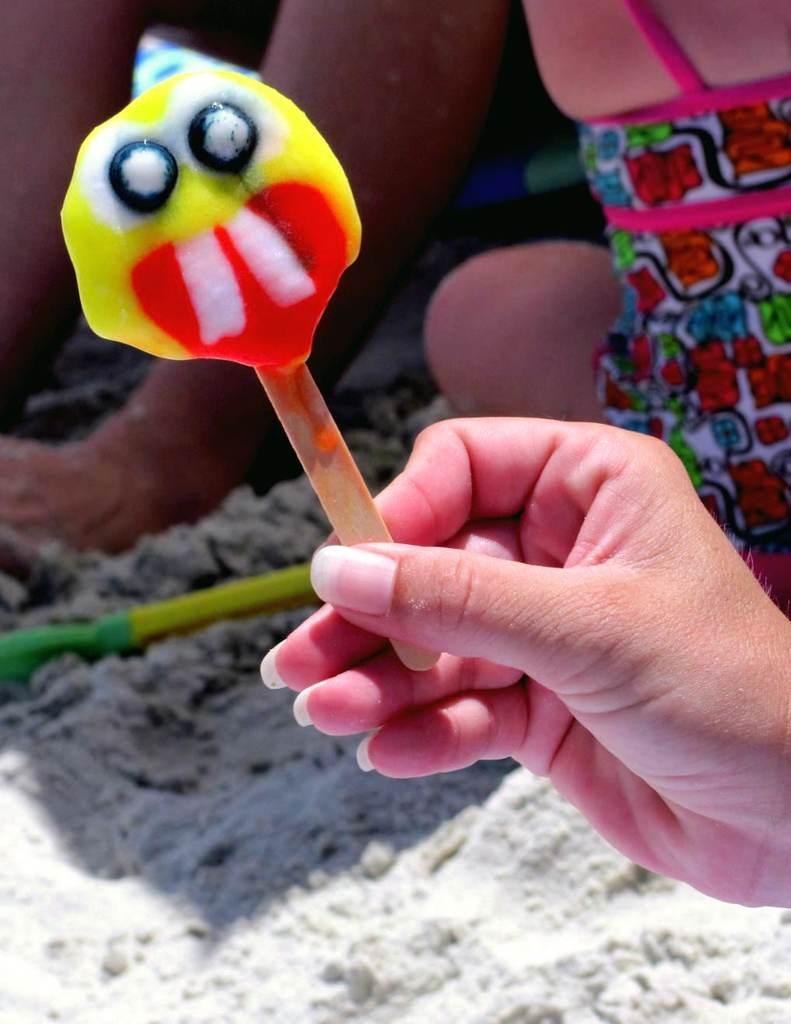In one or two sentences, can you explain what this image depicts? In this image there is some person holding an ice cream. In the background there is also some person. In the bottom there is ground. Yellow color object is also present. 